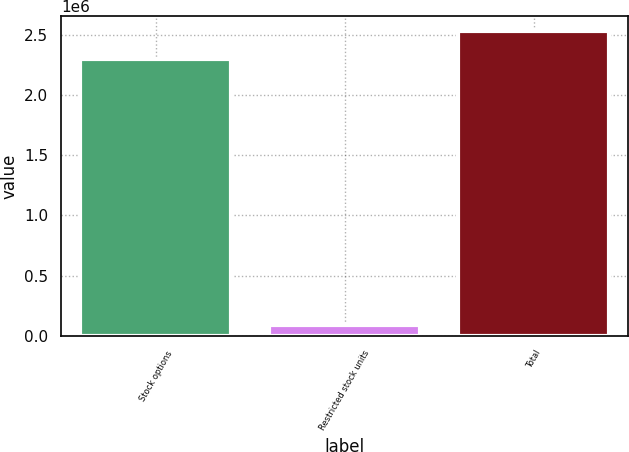Convert chart. <chart><loc_0><loc_0><loc_500><loc_500><bar_chart><fcel>Stock options<fcel>Restricted stock units<fcel>Total<nl><fcel>2.29816e+06<fcel>90625<fcel>2.52797e+06<nl></chart> 